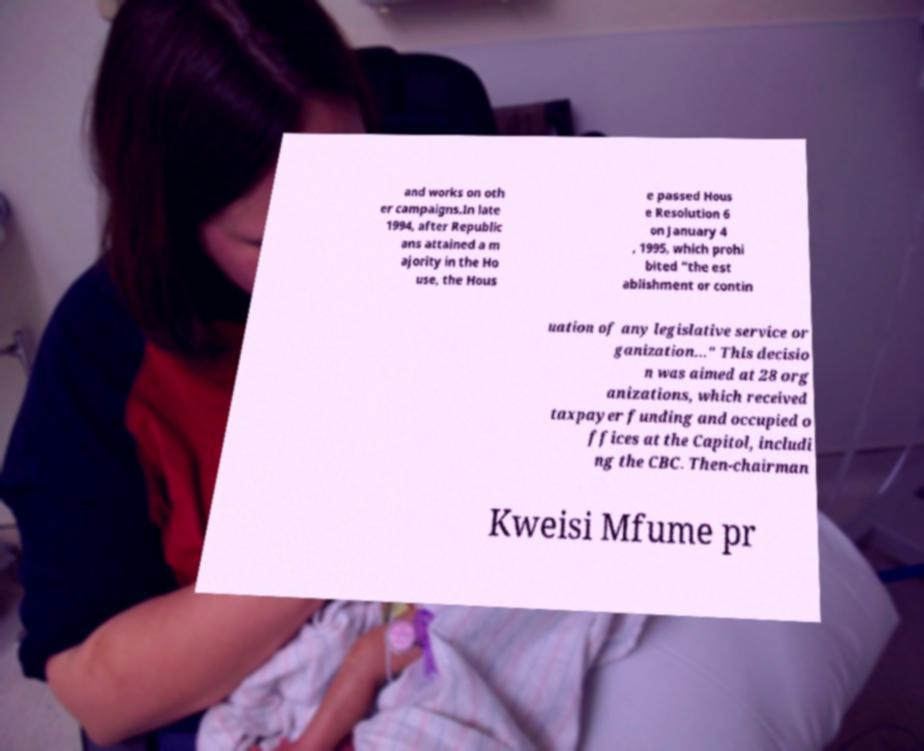Can you read and provide the text displayed in the image?This photo seems to have some interesting text. Can you extract and type it out for me? and works on oth er campaigns.In late 1994, after Republic ans attained a m ajority in the Ho use, the Hous e passed Hous e Resolution 6 on January 4 , 1995, which prohi bited “the est ablishment or contin uation of any legislative service or ganization..." This decisio n was aimed at 28 org anizations, which received taxpayer funding and occupied o ffices at the Capitol, includi ng the CBC. Then-chairman Kweisi Mfume pr 